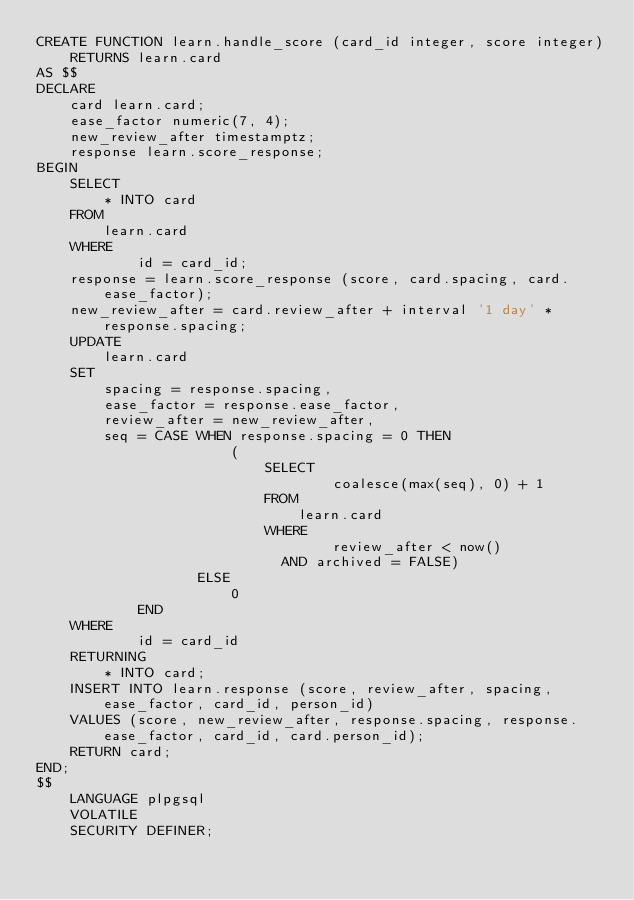Convert code to text. <code><loc_0><loc_0><loc_500><loc_500><_SQL_>CREATE FUNCTION learn.handle_score (card_id integer, score integer)
    RETURNS learn.card
AS $$
DECLARE
    card learn.card;
    ease_factor numeric(7, 4);
    new_review_after timestamptz;
    response learn.score_response;
BEGIN
    SELECT
        * INTO card
    FROM
        learn.card
    WHERE
            id = card_id;
    response = learn.score_response (score, card.spacing, card.ease_factor);
    new_review_after = card.review_after + interval '1 day' * response.spacing;
    UPDATE
        learn.card
    SET
        spacing = response.spacing,
        ease_factor = response.ease_factor,
        review_after = new_review_after,
        seq = CASE WHEN response.spacing = 0 THEN
                       (
                           SELECT
                                   coalesce(max(seq), 0) + 1
                           FROM
                               learn.card
                           WHERE
                                   review_after < now()
                             AND archived = FALSE)
                   ELSE
                       0
            END
    WHERE
            id = card_id
    RETURNING
        * INTO card;
    INSERT INTO learn.response (score, review_after, spacing, ease_factor, card_id, person_id)
    VALUES (score, new_review_after, response.spacing, response.ease_factor, card_id, card.person_id);
    RETURN card;
END;
$$
    LANGUAGE plpgsql
    VOLATILE
    SECURITY DEFINER;
</code> 